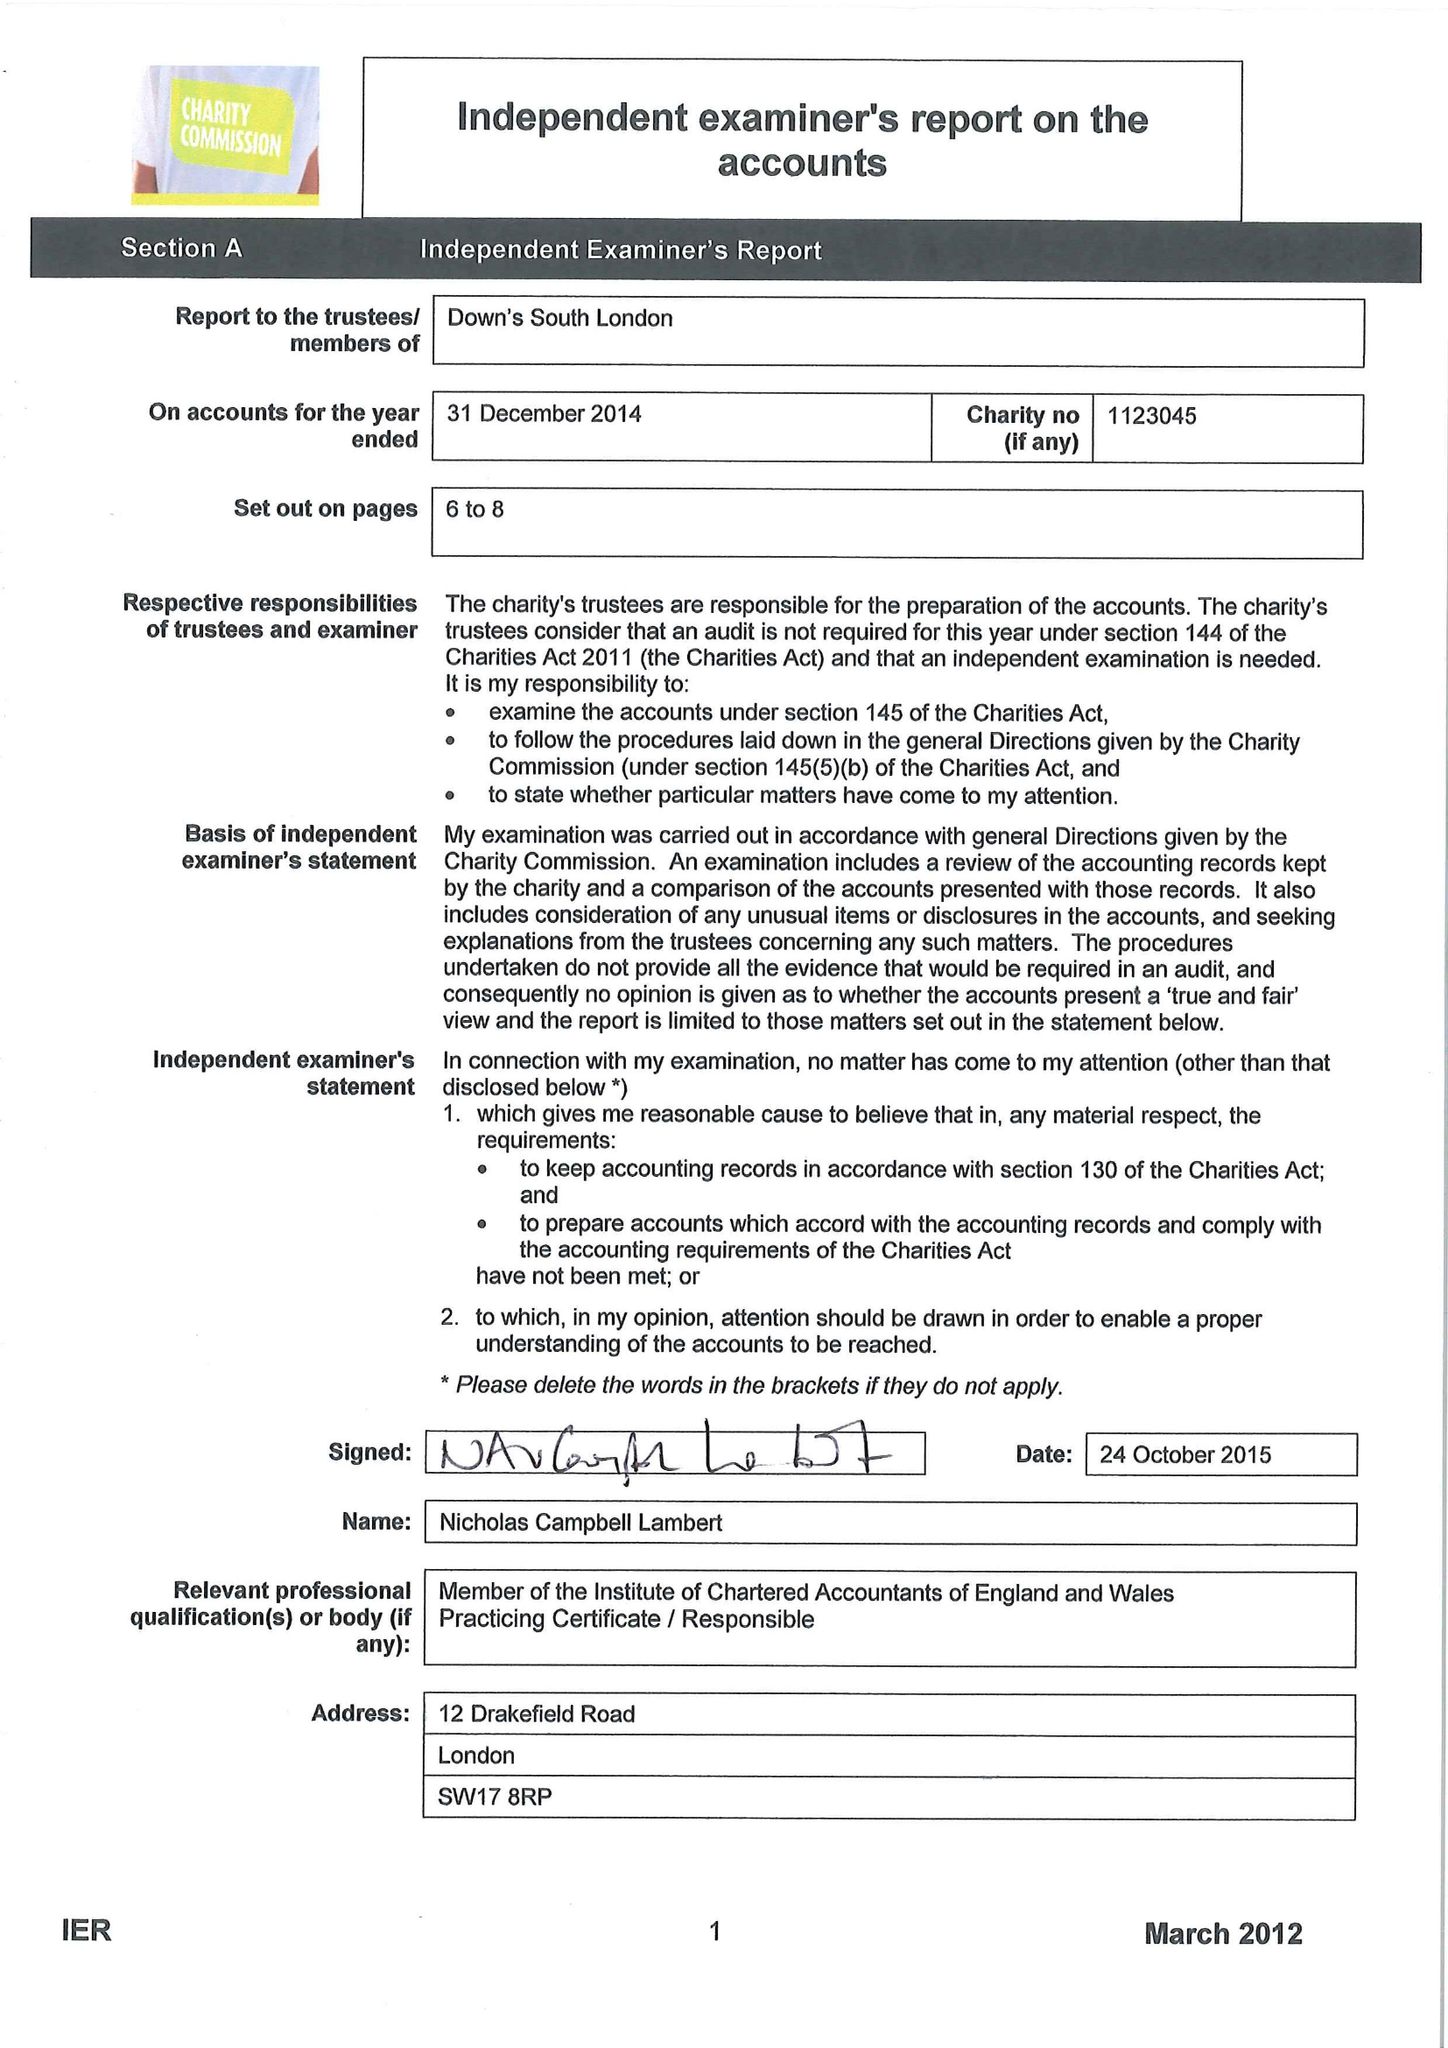What is the value for the report_date?
Answer the question using a single word or phrase. 2014-12-31 